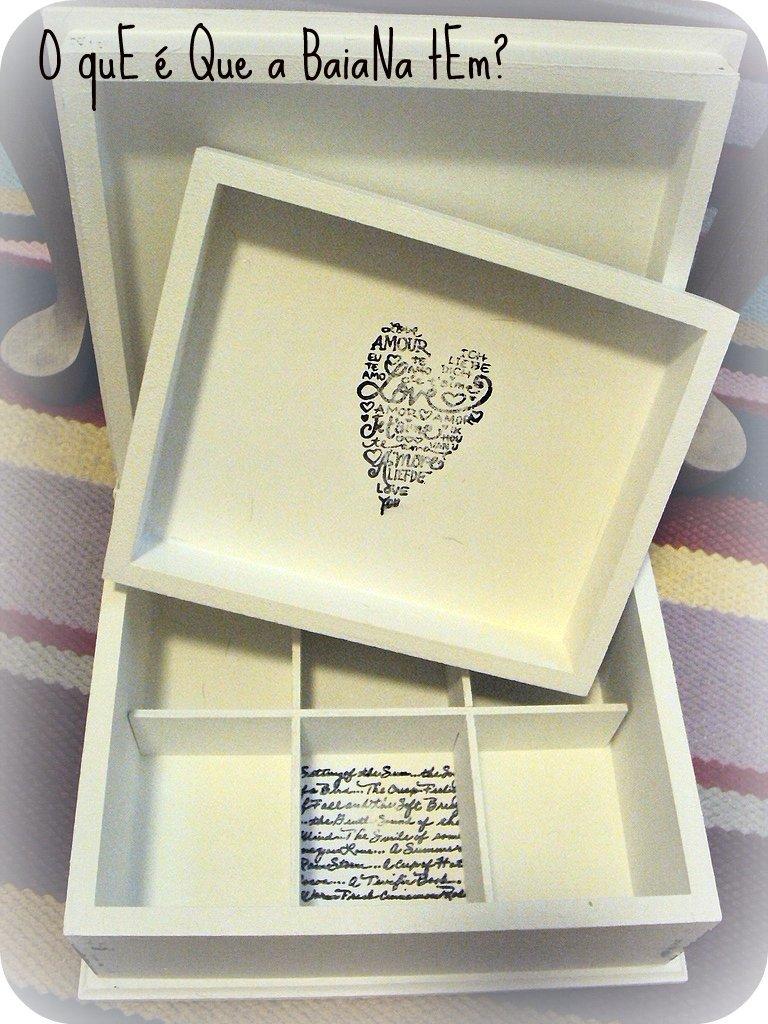What does the heart say?
Ensure brevity in your answer.  Love. Are the words on the box in the shape of a heart?
Your response must be concise. Yes. 